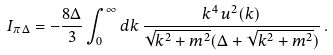Convert formula to latex. <formula><loc_0><loc_0><loc_500><loc_500>I _ { \pi \Delta } = - \frac { 8 \Delta } { 3 } \int _ { 0 } ^ { \infty } d k \, \frac { k ^ { 4 } \, u ^ { 2 } ( k ) } { \sqrt { k ^ { 2 } + m ^ { 2 } } ( \Delta + \sqrt { k ^ { 2 } + m ^ { 2 } } ) } \, .</formula> 